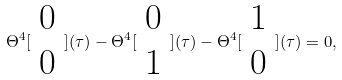Convert formula to latex. <formula><loc_0><loc_0><loc_500><loc_500>\Theta ^ { 4 } [ \begin{array} { c } 0 \\ 0 \end{array} ] ( \tau ) - \Theta ^ { 4 } [ \begin{array} { c } 0 \\ 1 \end{array} ] ( \tau ) - \Theta ^ { 4 } [ \begin{array} { c } 1 \\ 0 \end{array} ] ( \tau ) = 0 ,</formula> 